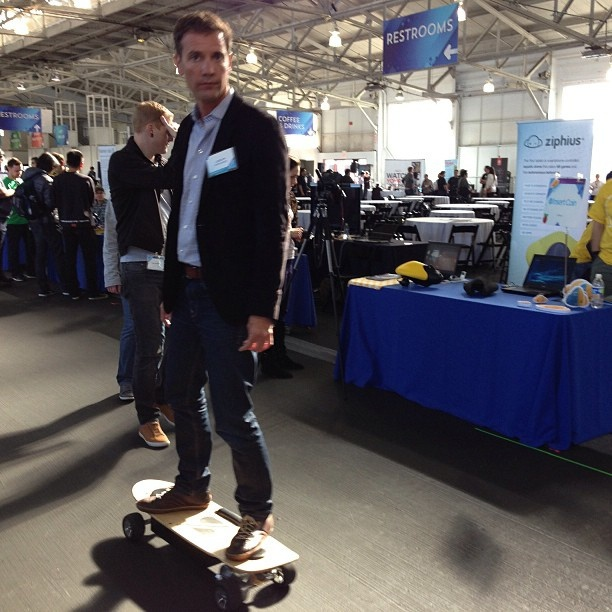Describe the objects in this image and their specific colors. I can see people in tan, black, gray, and maroon tones, chair in tan, black, gray, navy, and darkgray tones, people in tan, black, gray, maroon, and darkgray tones, skateboard in tan, white, black, gray, and maroon tones, and people in tan, black, gray, white, and darkgray tones in this image. 